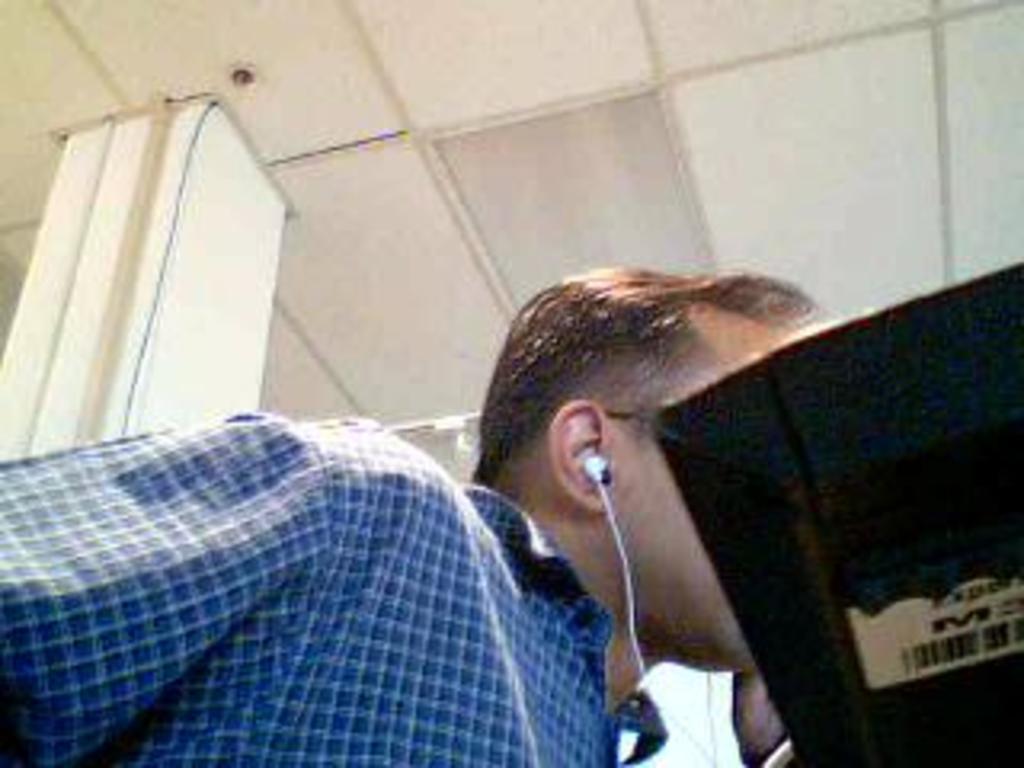Please provide a concise description of this image. In this picture there is a man who is wearing earphone and shirt. On the right we can see computer screen. On the top there is a ceiling. Here we can see pillar. 